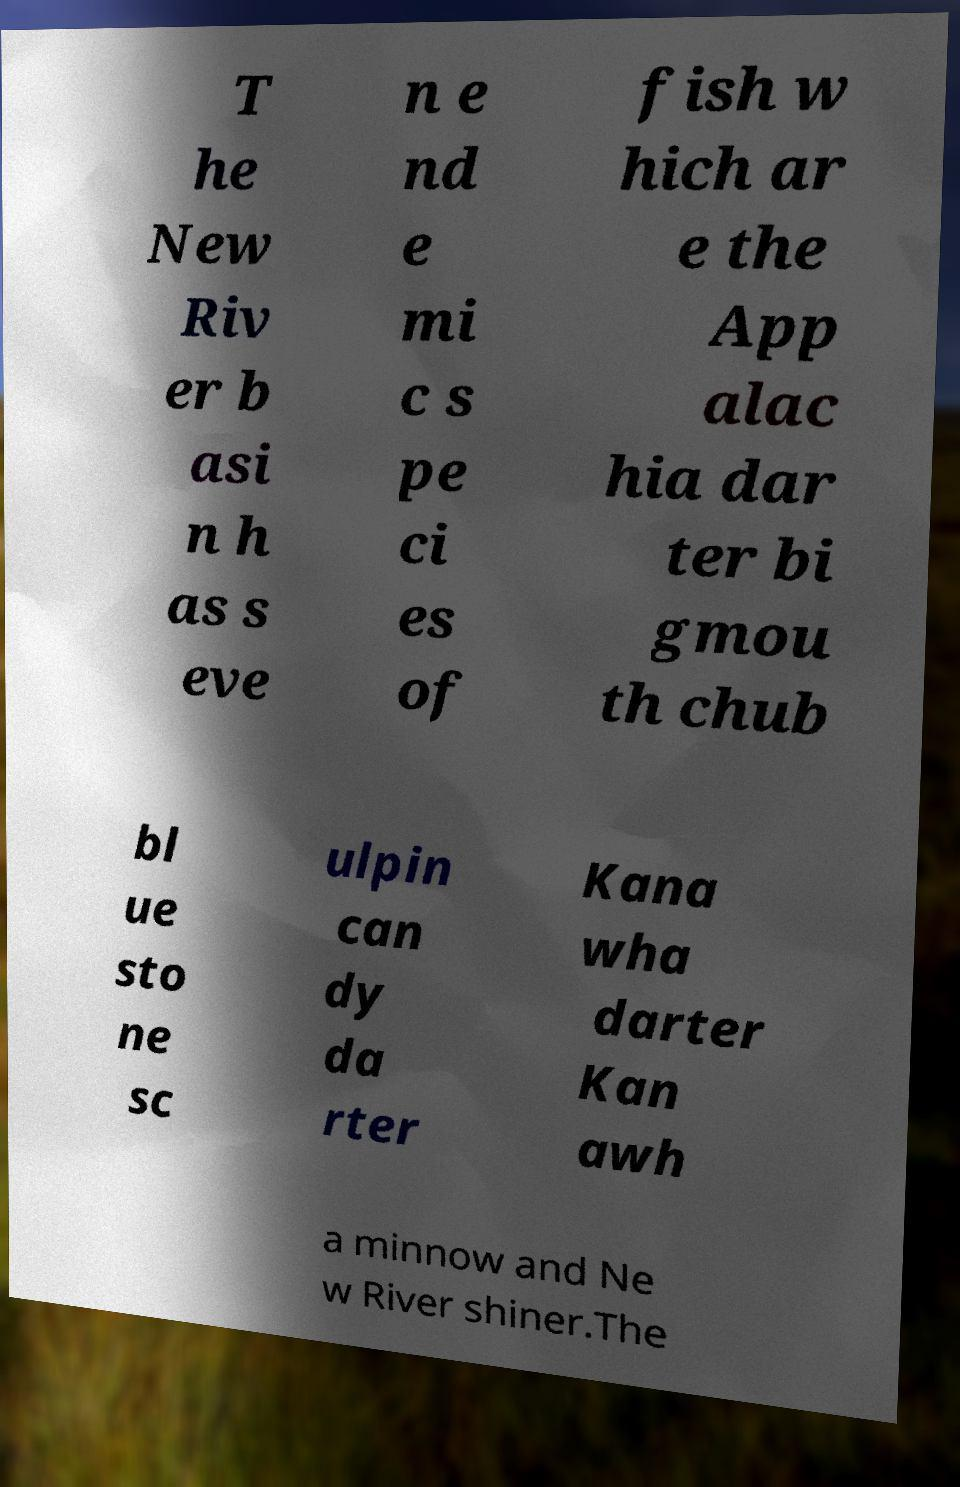What messages or text are displayed in this image? I need them in a readable, typed format. T he New Riv er b asi n h as s eve n e nd e mi c s pe ci es of fish w hich ar e the App alac hia dar ter bi gmou th chub bl ue sto ne sc ulpin can dy da rter Kana wha darter Kan awh a minnow and Ne w River shiner.The 